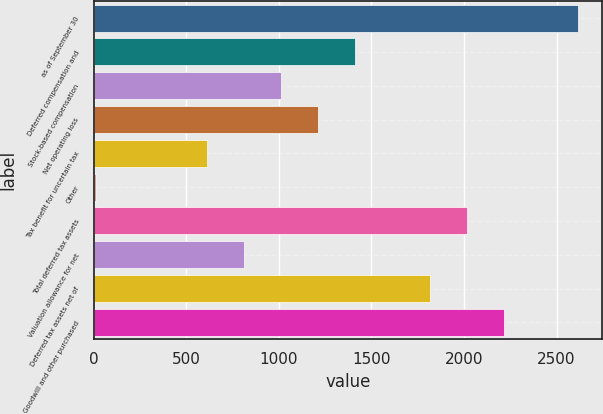Convert chart to OTSL. <chart><loc_0><loc_0><loc_500><loc_500><bar_chart><fcel>as of September 30<fcel>Deferred compensation and<fcel>Stock-based compensation<fcel>Net operating loss<fcel>Tax benefit for uncertain tax<fcel>Other<fcel>Total deferred tax assets<fcel>Valuation allowance for net<fcel>Deferred tax assets net of<fcel>Goodwill and other purchased<nl><fcel>2616.02<fcel>1413.98<fcel>1013.3<fcel>1213.64<fcel>612.62<fcel>11.6<fcel>2015<fcel>812.96<fcel>1814.66<fcel>2215.34<nl></chart> 